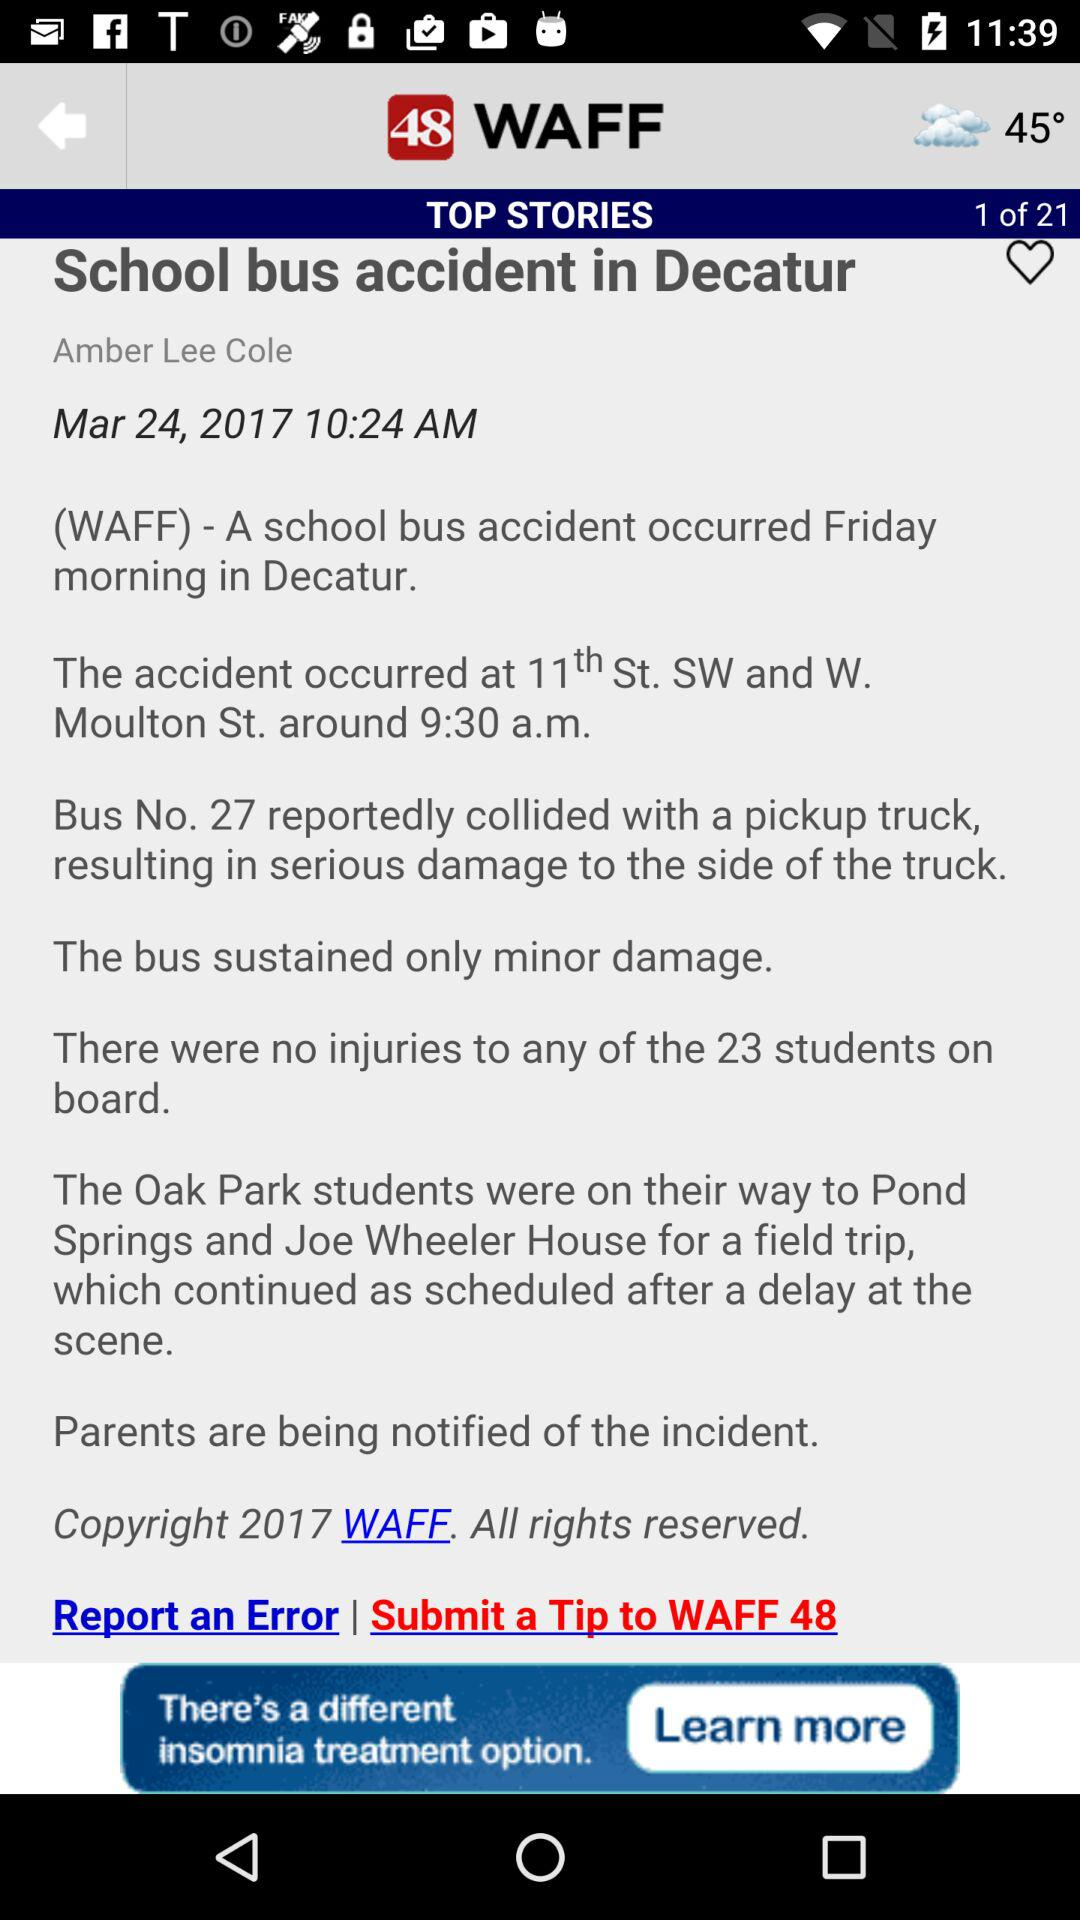At what time news school bus accident in Decatur is updated?
When the provided information is insufficient, respond with <no answer>. <no answer> 